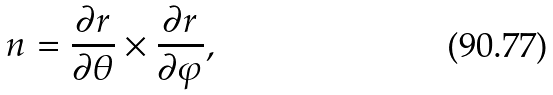Convert formula to latex. <formula><loc_0><loc_0><loc_500><loc_500>n = \frac { \partial r } { \partial \theta } \times \frac { \partial r } { \partial \varphi } ,</formula> 